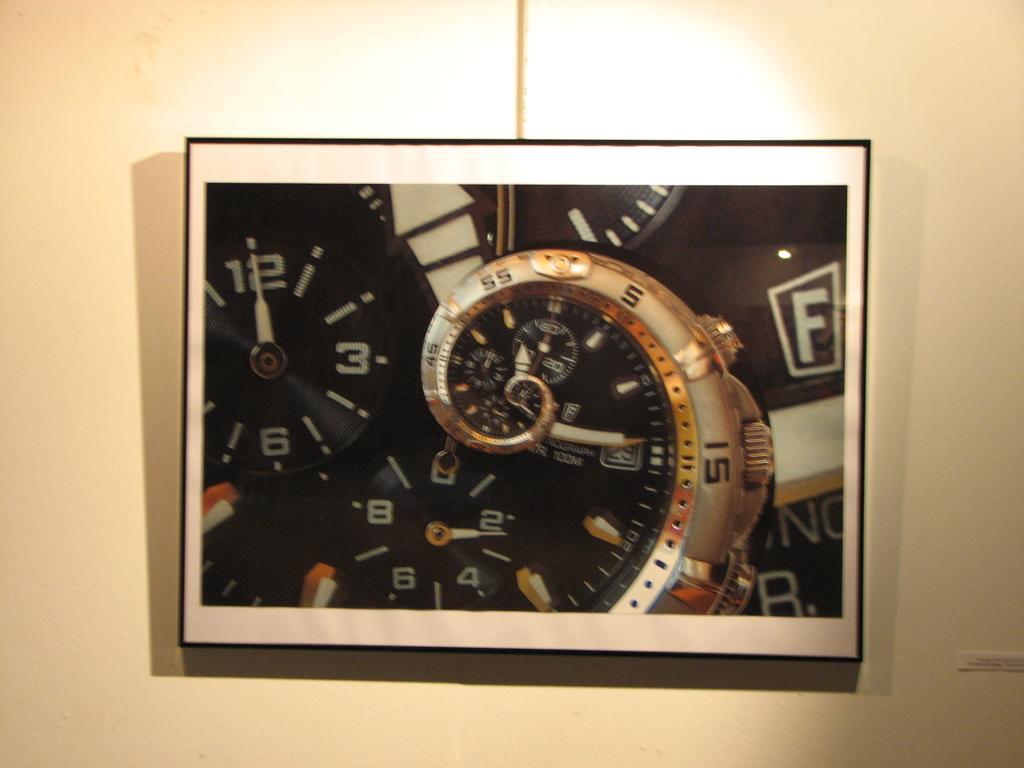In one or two sentences, can you explain what this image depicts? This image is taken indoors. In the background there is a wall. In the middle of the image there is a clock on the wall. 